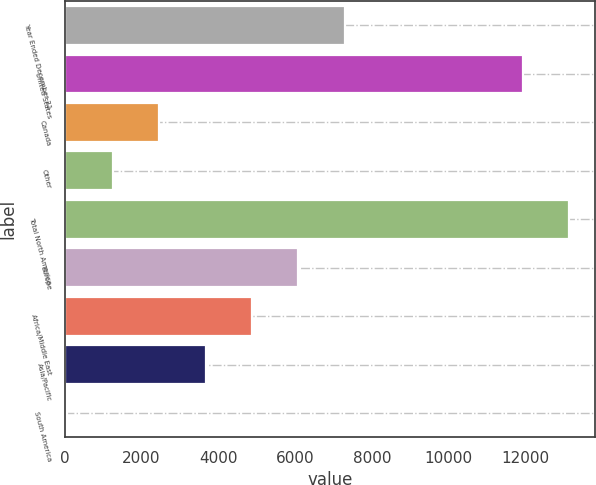Convert chart. <chart><loc_0><loc_0><loc_500><loc_500><bar_chart><fcel>Year Ended December 31<fcel>United States<fcel>Canada<fcel>Other<fcel>Total North America<fcel>Europe<fcel>Africa/Middle East<fcel>Asia/Pacific<fcel>South America<nl><fcel>7293.2<fcel>11942<fcel>2466.4<fcel>1259.7<fcel>13148.7<fcel>6086.5<fcel>4879.8<fcel>3673.1<fcel>53<nl></chart> 